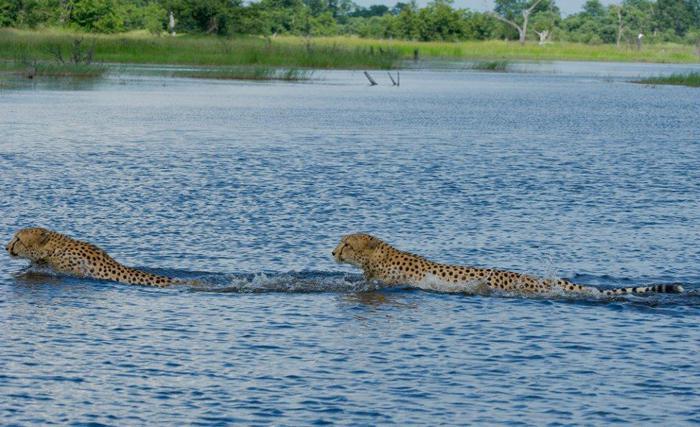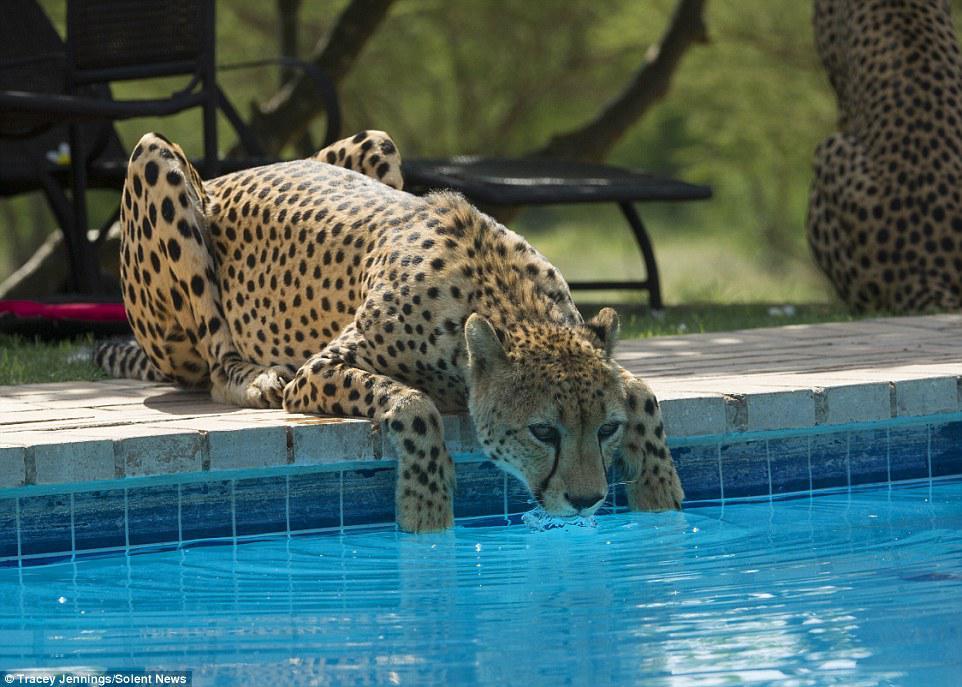The first image is the image on the left, the second image is the image on the right. For the images shown, is this caption "There is a leopard looking into a swimming pool in each image." true? Answer yes or no. No. The first image is the image on the left, the second image is the image on the right. For the images displayed, is the sentence "Each image shows at least one spotted wild cat leaning to drink out of a manmade swimming pool." factually correct? Answer yes or no. No. 